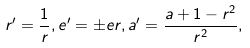Convert formula to latex. <formula><loc_0><loc_0><loc_500><loc_500>r ^ { \prime } = \frac { 1 } { r } , e ^ { \prime } = { \pm } e r , a ^ { \prime } = \frac { a + 1 - r ^ { 2 } } { r ^ { 2 } } ,</formula> 